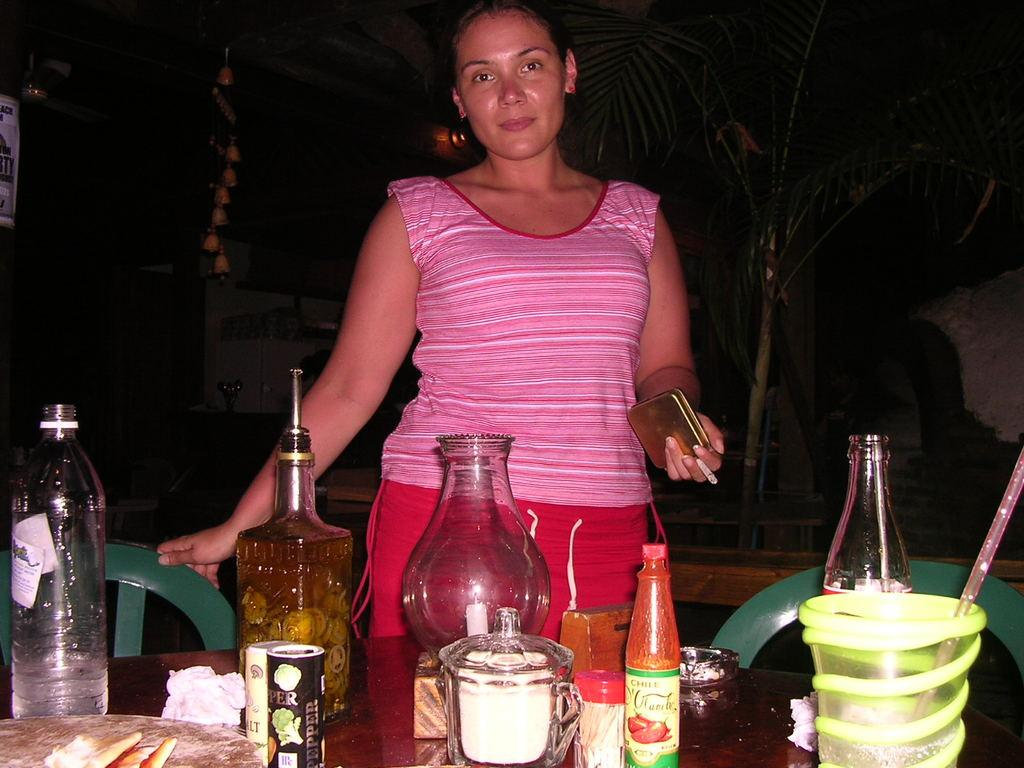Who is present in the image? There is a woman in the image. What is the woman holding in her hand? The woman is holding a cigarette and a wallet. What piece of furniture is in the image? There is a chair in the image. What items can be seen on the table? There are bottles and a cup on the table. What is the woman using to drink from the cup? There is a straw in the image, which the woman might be using to drink from the cup. Can you see a mitten being used to fan the woman in the image? No, there is no mitten or fan present in the image. 